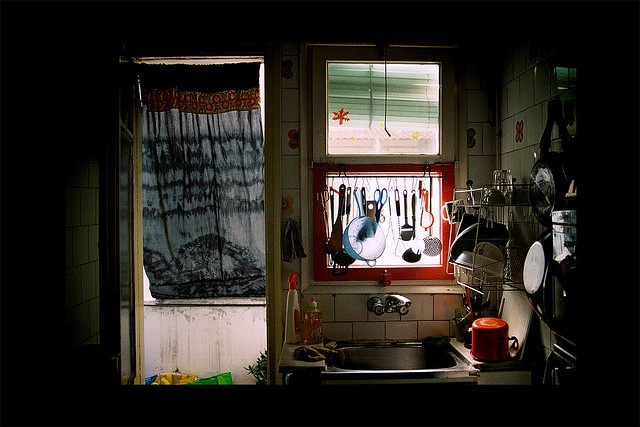Describe the objects in this image and their specific colors. I can see sink in black and gray tones, bottle in black, maroon, olive, and gray tones, bottle in black, maroon, olive, and gray tones, bowl in black and gray tones, and spoon in black, white, and maroon tones in this image. 